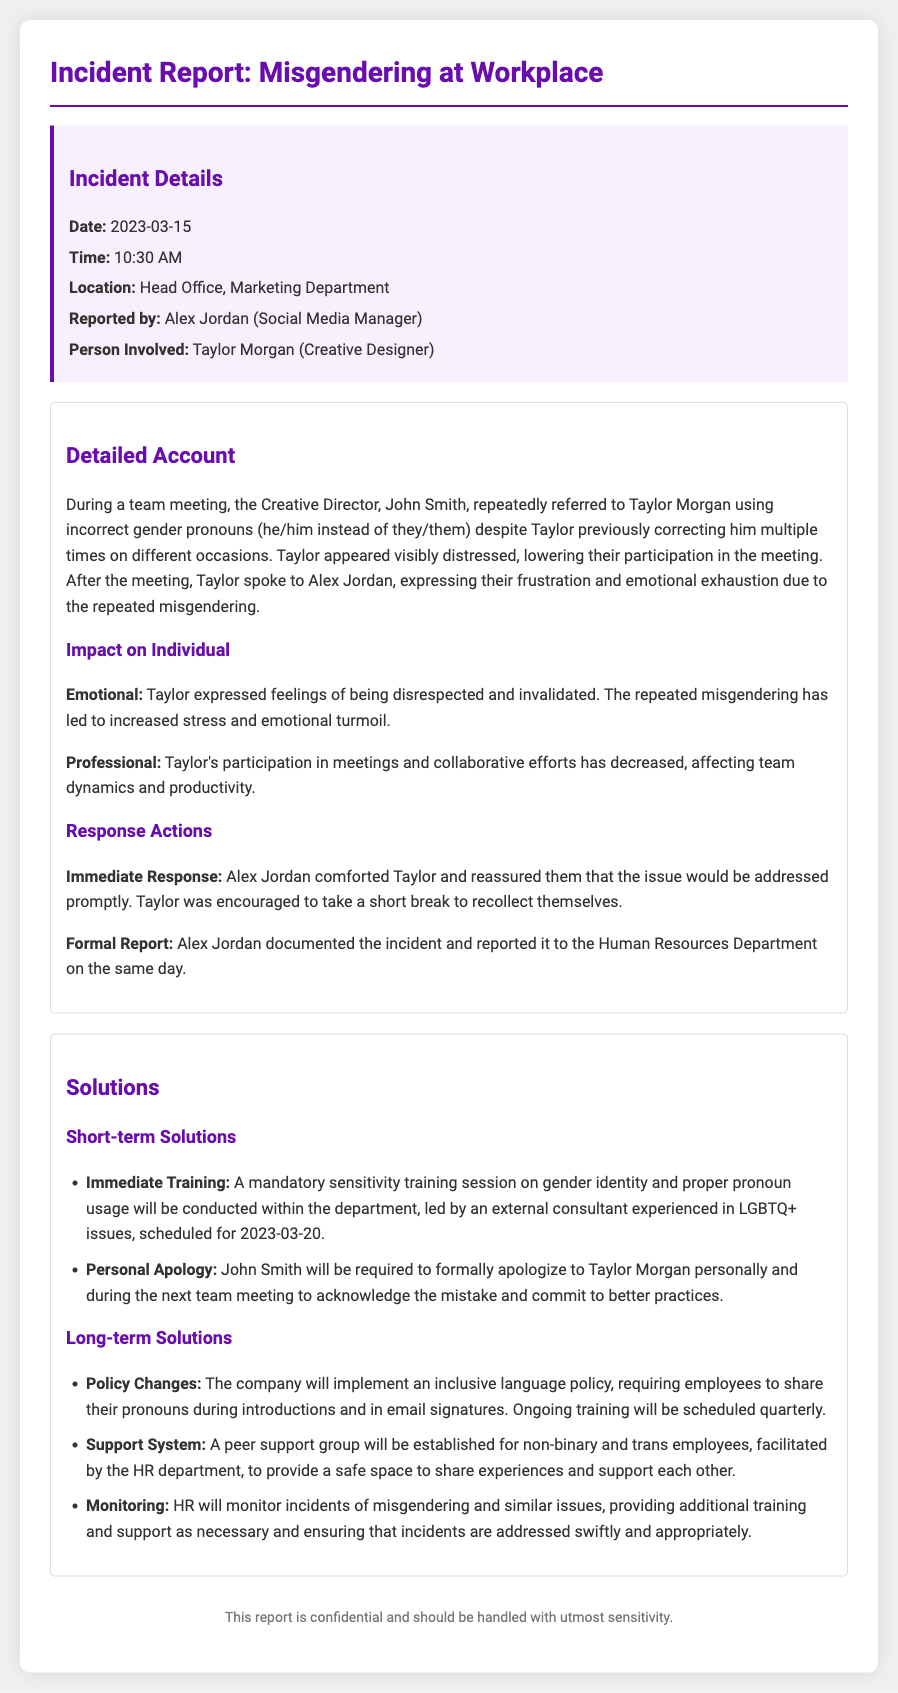What was the date of the incident? The date of the incident is specified in the report, which is 2023-03-15.
Answer: 2023-03-15 Who reported the incident? The report specifies that Alex Jordan reported the incident, making them the point of contact for this situation.
Answer: Alex Jordan What was the location of the incident? The document mentions that the incident took place in the Head Office, specifically in the Marketing Department.
Answer: Head Office, Marketing Department What immediate response was taken after the incident? The report details that Alex Jordan comforted Taylor and encouraged them to take a short break to recollect themselves after the incident.
Answer: Encouraged to take a short break What is one of the short-term solutions proposed? The report outlines that a mandatory sensitivity training session on gender identity will be conducted as a short-term solution to address the incident.
Answer: Mandatory sensitivity training session What will John Smith be required to do? According to the report, John Smith will be required to formally apologize to Taylor Morgan personally and during the next team meeting.
Answer: Formally apologize to Taylor Morgan What policy change will the company implement? The report states that the company will implement an inclusive language policy requiring employees to share their pronouns during introductions and in email signatures.
Answer: Inclusive language policy How will incidents of misgendering be monitored? The report specifies that HR will monitor incidents of misgendering and provide additional training and support as necessary to ensure issues are addressed.
Answer: HR will monitor incidents What was the impact on Taylor's professional participation? The document mentions that Taylor's participation in meetings and collaborative efforts has decreased, indicating a negative impact on their professional engagement.
Answer: Decreased participation in meetings 